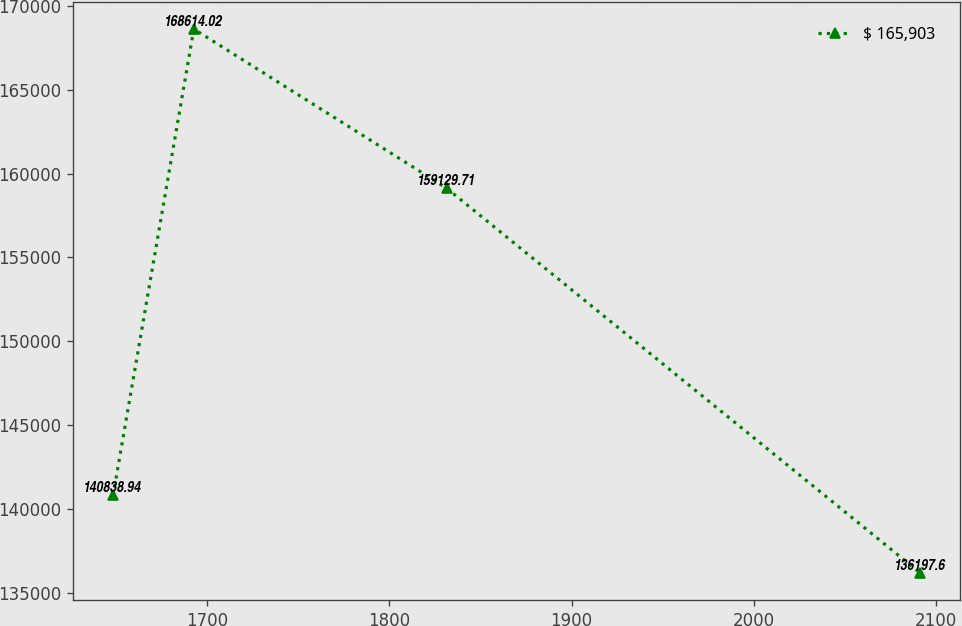<chart> <loc_0><loc_0><loc_500><loc_500><line_chart><ecel><fcel>$ 165,903<nl><fcel>1648.56<fcel>140839<nl><fcel>1692.83<fcel>168614<nl><fcel>1831.45<fcel>159130<nl><fcel>2091.21<fcel>136198<nl></chart> 